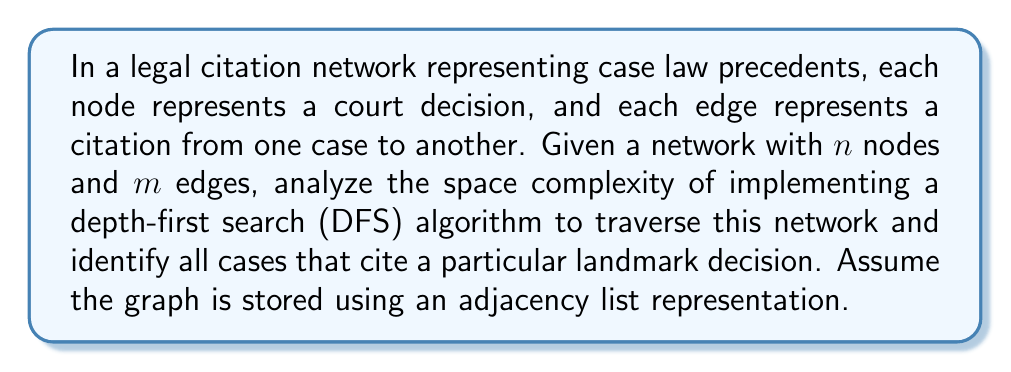Teach me how to tackle this problem. To analyze the space complexity of the DFS algorithm on this legal citation network, we need to consider the following components:

1. Graph representation:
   The adjacency list representation requires space to store all nodes and edges.
   - Space for nodes: $O(n)$
   - Space for edges: $O(m)$
   Total space for graph: $O(n + m)$

2. DFS algorithm implementation:
   a) Recursion stack:
      In the worst case, the DFS might traverse the entire depth of the graph.
      Maximum depth could be $n-1$ (in case of a linear chain of citations).
      Space complexity: $O(n)$

   b) Visited set:
      To keep track of visited nodes and avoid cycles, we need a set or array.
      Space complexity: $O(n)$

   c) Output storage:
      To store the list of cases citing the landmark decision.
      In the worst case, all cases might cite the landmark decision.
      Space complexity: $O(n)$

3. Additional variables:
   Constant amount of space for variables like counters, temporary storage, etc.
   Space complexity: $O(1)$

Combining all these components, the total space complexity is:
$$O(n + m) + O(n) + O(n) + O(n) + O(1) = O(n + m)$$

The dominant term is $O(n + m)$, which represents the space required to store the graph itself.

For a law student, it's important to note that this space complexity analysis helps in understanding the scalability of legal research tools. As the number of court decisions and citations grows, the memory requirements for analyzing the citation network increase linearly with the number of cases and citations, allowing for efficient exploration of legal precedents even in large databases.
Answer: The space complexity of implementing a depth-first search (DFS) algorithm on a legal citation network with $n$ nodes and $m$ edges, stored as an adjacency list, is $O(n + m)$. 